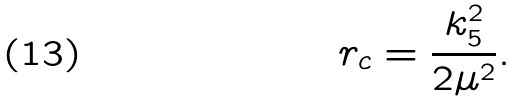<formula> <loc_0><loc_0><loc_500><loc_500>r _ { c } = \frac { k _ { 5 } ^ { 2 } } { 2 \mu ^ { 2 } } .</formula> 